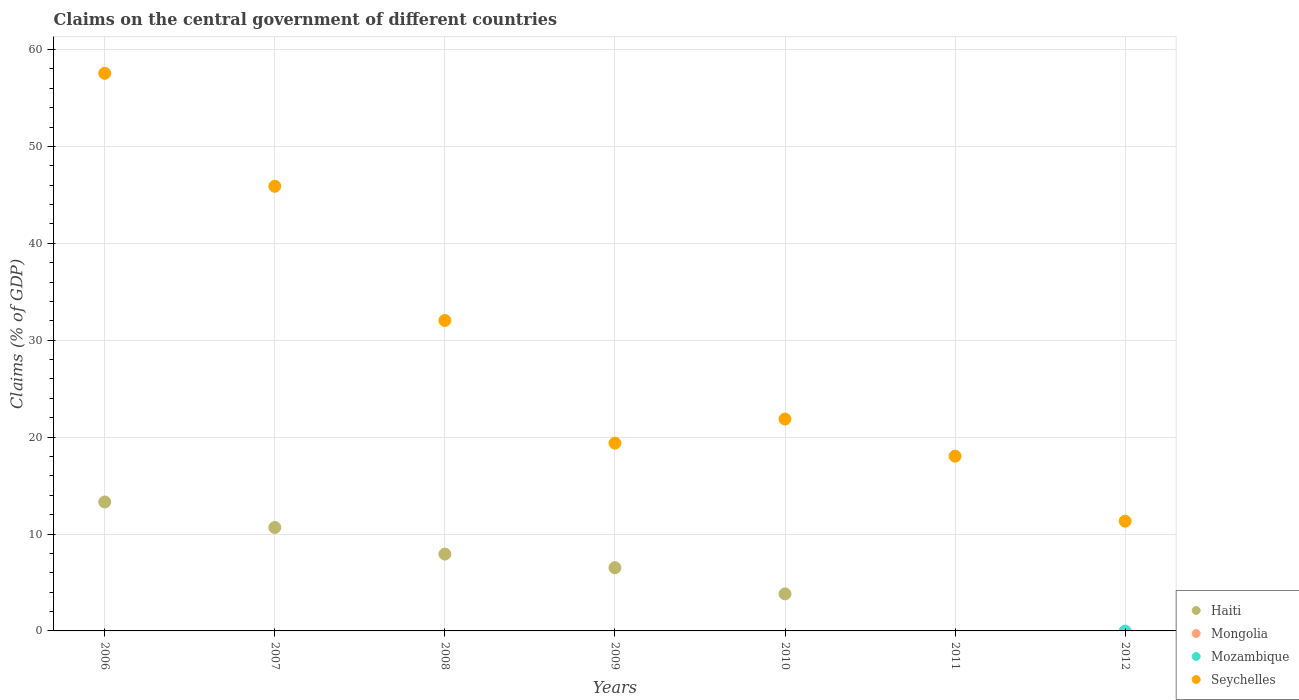Is the number of dotlines equal to the number of legend labels?
Ensure brevity in your answer.  No. What is the percentage of GDP claimed on the central government in Seychelles in 2011?
Give a very brief answer. 18.03. Across all years, what is the maximum percentage of GDP claimed on the central government in Seychelles?
Keep it short and to the point. 57.54. Across all years, what is the minimum percentage of GDP claimed on the central government in Seychelles?
Keep it short and to the point. 11.33. In which year was the percentage of GDP claimed on the central government in Seychelles maximum?
Offer a terse response. 2006. What is the total percentage of GDP claimed on the central government in Haiti in the graph?
Give a very brief answer. 42.26. What is the difference between the percentage of GDP claimed on the central government in Haiti in 2009 and that in 2010?
Offer a terse response. 2.7. In the year 2008, what is the difference between the percentage of GDP claimed on the central government in Haiti and percentage of GDP claimed on the central government in Seychelles?
Provide a short and direct response. -24.11. What is the ratio of the percentage of GDP claimed on the central government in Seychelles in 2010 to that in 2011?
Offer a very short reply. 1.21. Is the difference between the percentage of GDP claimed on the central government in Haiti in 2009 and 2010 greater than the difference between the percentage of GDP claimed on the central government in Seychelles in 2009 and 2010?
Make the answer very short. Yes. What is the difference between the highest and the second highest percentage of GDP claimed on the central government in Seychelles?
Ensure brevity in your answer.  11.66. What is the difference between the highest and the lowest percentage of GDP claimed on the central government in Haiti?
Your response must be concise. 13.3. In how many years, is the percentage of GDP claimed on the central government in Mozambique greater than the average percentage of GDP claimed on the central government in Mozambique taken over all years?
Your answer should be compact. 0. Is it the case that in every year, the sum of the percentage of GDP claimed on the central government in Mozambique and percentage of GDP claimed on the central government in Haiti  is greater than the sum of percentage of GDP claimed on the central government in Mongolia and percentage of GDP claimed on the central government in Seychelles?
Give a very brief answer. No. Is it the case that in every year, the sum of the percentage of GDP claimed on the central government in Haiti and percentage of GDP claimed on the central government in Seychelles  is greater than the percentage of GDP claimed on the central government in Mongolia?
Your answer should be compact. Yes. Where does the legend appear in the graph?
Provide a succinct answer. Bottom right. How are the legend labels stacked?
Your response must be concise. Vertical. What is the title of the graph?
Provide a short and direct response. Claims on the central government of different countries. Does "St. Kitts and Nevis" appear as one of the legend labels in the graph?
Ensure brevity in your answer.  No. What is the label or title of the X-axis?
Make the answer very short. Years. What is the label or title of the Y-axis?
Your answer should be very brief. Claims (% of GDP). What is the Claims (% of GDP) of Haiti in 2006?
Keep it short and to the point. 13.3. What is the Claims (% of GDP) of Mongolia in 2006?
Keep it short and to the point. 0. What is the Claims (% of GDP) in Seychelles in 2006?
Make the answer very short. 57.54. What is the Claims (% of GDP) of Haiti in 2007?
Your answer should be very brief. 10.67. What is the Claims (% of GDP) of Mongolia in 2007?
Your answer should be very brief. 0. What is the Claims (% of GDP) of Mozambique in 2007?
Provide a succinct answer. 0. What is the Claims (% of GDP) of Seychelles in 2007?
Keep it short and to the point. 45.88. What is the Claims (% of GDP) in Haiti in 2008?
Your answer should be compact. 7.93. What is the Claims (% of GDP) in Mozambique in 2008?
Your answer should be very brief. 0. What is the Claims (% of GDP) in Seychelles in 2008?
Give a very brief answer. 32.04. What is the Claims (% of GDP) in Haiti in 2009?
Keep it short and to the point. 6.53. What is the Claims (% of GDP) of Mongolia in 2009?
Your answer should be compact. 0. What is the Claims (% of GDP) in Mozambique in 2009?
Your response must be concise. 0. What is the Claims (% of GDP) in Seychelles in 2009?
Your answer should be very brief. 19.38. What is the Claims (% of GDP) of Haiti in 2010?
Your response must be concise. 3.82. What is the Claims (% of GDP) of Mozambique in 2010?
Provide a short and direct response. 0. What is the Claims (% of GDP) of Seychelles in 2010?
Your response must be concise. 21.87. What is the Claims (% of GDP) of Haiti in 2011?
Your answer should be compact. 0. What is the Claims (% of GDP) of Mongolia in 2011?
Make the answer very short. 0. What is the Claims (% of GDP) of Seychelles in 2011?
Ensure brevity in your answer.  18.03. What is the Claims (% of GDP) in Haiti in 2012?
Offer a terse response. 0. What is the Claims (% of GDP) in Seychelles in 2012?
Make the answer very short. 11.33. Across all years, what is the maximum Claims (% of GDP) of Haiti?
Your answer should be compact. 13.3. Across all years, what is the maximum Claims (% of GDP) in Seychelles?
Your answer should be compact. 57.54. Across all years, what is the minimum Claims (% of GDP) in Haiti?
Ensure brevity in your answer.  0. Across all years, what is the minimum Claims (% of GDP) in Seychelles?
Keep it short and to the point. 11.33. What is the total Claims (% of GDP) of Haiti in the graph?
Offer a very short reply. 42.26. What is the total Claims (% of GDP) of Mongolia in the graph?
Offer a terse response. 0. What is the total Claims (% of GDP) of Seychelles in the graph?
Your answer should be compact. 206.07. What is the difference between the Claims (% of GDP) in Haiti in 2006 and that in 2007?
Offer a very short reply. 2.63. What is the difference between the Claims (% of GDP) in Seychelles in 2006 and that in 2007?
Your response must be concise. 11.66. What is the difference between the Claims (% of GDP) of Haiti in 2006 and that in 2008?
Your answer should be very brief. 5.37. What is the difference between the Claims (% of GDP) in Seychelles in 2006 and that in 2008?
Offer a very short reply. 25.51. What is the difference between the Claims (% of GDP) of Haiti in 2006 and that in 2009?
Ensure brevity in your answer.  6.78. What is the difference between the Claims (% of GDP) of Seychelles in 2006 and that in 2009?
Offer a very short reply. 38.16. What is the difference between the Claims (% of GDP) of Haiti in 2006 and that in 2010?
Make the answer very short. 9.48. What is the difference between the Claims (% of GDP) of Seychelles in 2006 and that in 2010?
Provide a short and direct response. 35.68. What is the difference between the Claims (% of GDP) in Seychelles in 2006 and that in 2011?
Provide a short and direct response. 39.51. What is the difference between the Claims (% of GDP) in Seychelles in 2006 and that in 2012?
Make the answer very short. 46.22. What is the difference between the Claims (% of GDP) in Haiti in 2007 and that in 2008?
Your answer should be compact. 2.74. What is the difference between the Claims (% of GDP) in Seychelles in 2007 and that in 2008?
Make the answer very short. 13.85. What is the difference between the Claims (% of GDP) in Haiti in 2007 and that in 2009?
Keep it short and to the point. 4.15. What is the difference between the Claims (% of GDP) of Seychelles in 2007 and that in 2009?
Provide a succinct answer. 26.5. What is the difference between the Claims (% of GDP) in Haiti in 2007 and that in 2010?
Provide a succinct answer. 6.85. What is the difference between the Claims (% of GDP) in Seychelles in 2007 and that in 2010?
Your response must be concise. 24.02. What is the difference between the Claims (% of GDP) in Seychelles in 2007 and that in 2011?
Your response must be concise. 27.85. What is the difference between the Claims (% of GDP) of Seychelles in 2007 and that in 2012?
Your answer should be very brief. 34.56. What is the difference between the Claims (% of GDP) in Haiti in 2008 and that in 2009?
Provide a short and direct response. 1.41. What is the difference between the Claims (% of GDP) of Seychelles in 2008 and that in 2009?
Keep it short and to the point. 12.66. What is the difference between the Claims (% of GDP) in Haiti in 2008 and that in 2010?
Offer a very short reply. 4.11. What is the difference between the Claims (% of GDP) of Seychelles in 2008 and that in 2010?
Give a very brief answer. 10.17. What is the difference between the Claims (% of GDP) of Seychelles in 2008 and that in 2011?
Provide a succinct answer. 14. What is the difference between the Claims (% of GDP) of Seychelles in 2008 and that in 2012?
Provide a succinct answer. 20.71. What is the difference between the Claims (% of GDP) in Haiti in 2009 and that in 2010?
Keep it short and to the point. 2.7. What is the difference between the Claims (% of GDP) in Seychelles in 2009 and that in 2010?
Your answer should be compact. -2.49. What is the difference between the Claims (% of GDP) in Seychelles in 2009 and that in 2011?
Give a very brief answer. 1.35. What is the difference between the Claims (% of GDP) of Seychelles in 2009 and that in 2012?
Your answer should be compact. 8.06. What is the difference between the Claims (% of GDP) in Seychelles in 2010 and that in 2011?
Keep it short and to the point. 3.83. What is the difference between the Claims (% of GDP) of Seychelles in 2010 and that in 2012?
Give a very brief answer. 10.54. What is the difference between the Claims (% of GDP) in Seychelles in 2011 and that in 2012?
Make the answer very short. 6.71. What is the difference between the Claims (% of GDP) of Haiti in 2006 and the Claims (% of GDP) of Seychelles in 2007?
Your answer should be very brief. -32.58. What is the difference between the Claims (% of GDP) in Haiti in 2006 and the Claims (% of GDP) in Seychelles in 2008?
Your answer should be very brief. -18.73. What is the difference between the Claims (% of GDP) in Haiti in 2006 and the Claims (% of GDP) in Seychelles in 2009?
Make the answer very short. -6.08. What is the difference between the Claims (% of GDP) in Haiti in 2006 and the Claims (% of GDP) in Seychelles in 2010?
Give a very brief answer. -8.56. What is the difference between the Claims (% of GDP) in Haiti in 2006 and the Claims (% of GDP) in Seychelles in 2011?
Provide a succinct answer. -4.73. What is the difference between the Claims (% of GDP) in Haiti in 2006 and the Claims (% of GDP) in Seychelles in 2012?
Ensure brevity in your answer.  1.98. What is the difference between the Claims (% of GDP) of Haiti in 2007 and the Claims (% of GDP) of Seychelles in 2008?
Your response must be concise. -21.37. What is the difference between the Claims (% of GDP) of Haiti in 2007 and the Claims (% of GDP) of Seychelles in 2009?
Your response must be concise. -8.71. What is the difference between the Claims (% of GDP) of Haiti in 2007 and the Claims (% of GDP) of Seychelles in 2010?
Offer a very short reply. -11.19. What is the difference between the Claims (% of GDP) of Haiti in 2007 and the Claims (% of GDP) of Seychelles in 2011?
Offer a terse response. -7.36. What is the difference between the Claims (% of GDP) in Haiti in 2007 and the Claims (% of GDP) in Seychelles in 2012?
Ensure brevity in your answer.  -0.65. What is the difference between the Claims (% of GDP) of Haiti in 2008 and the Claims (% of GDP) of Seychelles in 2009?
Your answer should be compact. -11.45. What is the difference between the Claims (% of GDP) in Haiti in 2008 and the Claims (% of GDP) in Seychelles in 2010?
Offer a very short reply. -13.93. What is the difference between the Claims (% of GDP) in Haiti in 2008 and the Claims (% of GDP) in Seychelles in 2011?
Your answer should be very brief. -10.1. What is the difference between the Claims (% of GDP) in Haiti in 2008 and the Claims (% of GDP) in Seychelles in 2012?
Give a very brief answer. -3.39. What is the difference between the Claims (% of GDP) of Haiti in 2009 and the Claims (% of GDP) of Seychelles in 2010?
Your answer should be very brief. -15.34. What is the difference between the Claims (% of GDP) of Haiti in 2009 and the Claims (% of GDP) of Seychelles in 2011?
Make the answer very short. -11.51. What is the difference between the Claims (% of GDP) in Haiti in 2009 and the Claims (% of GDP) in Seychelles in 2012?
Make the answer very short. -4.8. What is the difference between the Claims (% of GDP) in Haiti in 2010 and the Claims (% of GDP) in Seychelles in 2011?
Your response must be concise. -14.21. What is the difference between the Claims (% of GDP) of Haiti in 2010 and the Claims (% of GDP) of Seychelles in 2012?
Your answer should be very brief. -7.5. What is the average Claims (% of GDP) in Haiti per year?
Ensure brevity in your answer.  6.04. What is the average Claims (% of GDP) of Mongolia per year?
Your answer should be compact. 0. What is the average Claims (% of GDP) of Mozambique per year?
Your answer should be very brief. 0. What is the average Claims (% of GDP) of Seychelles per year?
Provide a succinct answer. 29.44. In the year 2006, what is the difference between the Claims (% of GDP) in Haiti and Claims (% of GDP) in Seychelles?
Offer a very short reply. -44.24. In the year 2007, what is the difference between the Claims (% of GDP) of Haiti and Claims (% of GDP) of Seychelles?
Offer a very short reply. -35.21. In the year 2008, what is the difference between the Claims (% of GDP) in Haiti and Claims (% of GDP) in Seychelles?
Ensure brevity in your answer.  -24.11. In the year 2009, what is the difference between the Claims (% of GDP) of Haiti and Claims (% of GDP) of Seychelles?
Keep it short and to the point. -12.86. In the year 2010, what is the difference between the Claims (% of GDP) of Haiti and Claims (% of GDP) of Seychelles?
Your answer should be compact. -18.04. What is the ratio of the Claims (% of GDP) in Haiti in 2006 to that in 2007?
Your answer should be compact. 1.25. What is the ratio of the Claims (% of GDP) in Seychelles in 2006 to that in 2007?
Make the answer very short. 1.25. What is the ratio of the Claims (% of GDP) in Haiti in 2006 to that in 2008?
Provide a short and direct response. 1.68. What is the ratio of the Claims (% of GDP) of Seychelles in 2006 to that in 2008?
Provide a short and direct response. 1.8. What is the ratio of the Claims (% of GDP) in Haiti in 2006 to that in 2009?
Make the answer very short. 2.04. What is the ratio of the Claims (% of GDP) of Seychelles in 2006 to that in 2009?
Your answer should be compact. 2.97. What is the ratio of the Claims (% of GDP) in Haiti in 2006 to that in 2010?
Your answer should be very brief. 3.48. What is the ratio of the Claims (% of GDP) of Seychelles in 2006 to that in 2010?
Offer a very short reply. 2.63. What is the ratio of the Claims (% of GDP) in Seychelles in 2006 to that in 2011?
Keep it short and to the point. 3.19. What is the ratio of the Claims (% of GDP) of Seychelles in 2006 to that in 2012?
Offer a very short reply. 5.08. What is the ratio of the Claims (% of GDP) in Haiti in 2007 to that in 2008?
Your response must be concise. 1.35. What is the ratio of the Claims (% of GDP) in Seychelles in 2007 to that in 2008?
Keep it short and to the point. 1.43. What is the ratio of the Claims (% of GDP) in Haiti in 2007 to that in 2009?
Provide a short and direct response. 1.64. What is the ratio of the Claims (% of GDP) of Seychelles in 2007 to that in 2009?
Give a very brief answer. 2.37. What is the ratio of the Claims (% of GDP) in Haiti in 2007 to that in 2010?
Provide a succinct answer. 2.79. What is the ratio of the Claims (% of GDP) of Seychelles in 2007 to that in 2010?
Provide a succinct answer. 2.1. What is the ratio of the Claims (% of GDP) in Seychelles in 2007 to that in 2011?
Keep it short and to the point. 2.54. What is the ratio of the Claims (% of GDP) of Seychelles in 2007 to that in 2012?
Your answer should be compact. 4.05. What is the ratio of the Claims (% of GDP) in Haiti in 2008 to that in 2009?
Provide a succinct answer. 1.22. What is the ratio of the Claims (% of GDP) of Seychelles in 2008 to that in 2009?
Make the answer very short. 1.65. What is the ratio of the Claims (% of GDP) in Haiti in 2008 to that in 2010?
Your answer should be very brief. 2.07. What is the ratio of the Claims (% of GDP) of Seychelles in 2008 to that in 2010?
Offer a very short reply. 1.47. What is the ratio of the Claims (% of GDP) of Seychelles in 2008 to that in 2011?
Your response must be concise. 1.78. What is the ratio of the Claims (% of GDP) in Seychelles in 2008 to that in 2012?
Offer a very short reply. 2.83. What is the ratio of the Claims (% of GDP) of Haiti in 2009 to that in 2010?
Give a very brief answer. 1.71. What is the ratio of the Claims (% of GDP) in Seychelles in 2009 to that in 2010?
Ensure brevity in your answer.  0.89. What is the ratio of the Claims (% of GDP) in Seychelles in 2009 to that in 2011?
Your answer should be compact. 1.07. What is the ratio of the Claims (% of GDP) in Seychelles in 2009 to that in 2012?
Provide a short and direct response. 1.71. What is the ratio of the Claims (% of GDP) in Seychelles in 2010 to that in 2011?
Your answer should be compact. 1.21. What is the ratio of the Claims (% of GDP) of Seychelles in 2010 to that in 2012?
Provide a short and direct response. 1.93. What is the ratio of the Claims (% of GDP) in Seychelles in 2011 to that in 2012?
Provide a succinct answer. 1.59. What is the difference between the highest and the second highest Claims (% of GDP) in Haiti?
Offer a very short reply. 2.63. What is the difference between the highest and the second highest Claims (% of GDP) of Seychelles?
Your answer should be very brief. 11.66. What is the difference between the highest and the lowest Claims (% of GDP) of Haiti?
Ensure brevity in your answer.  13.3. What is the difference between the highest and the lowest Claims (% of GDP) of Seychelles?
Your response must be concise. 46.22. 